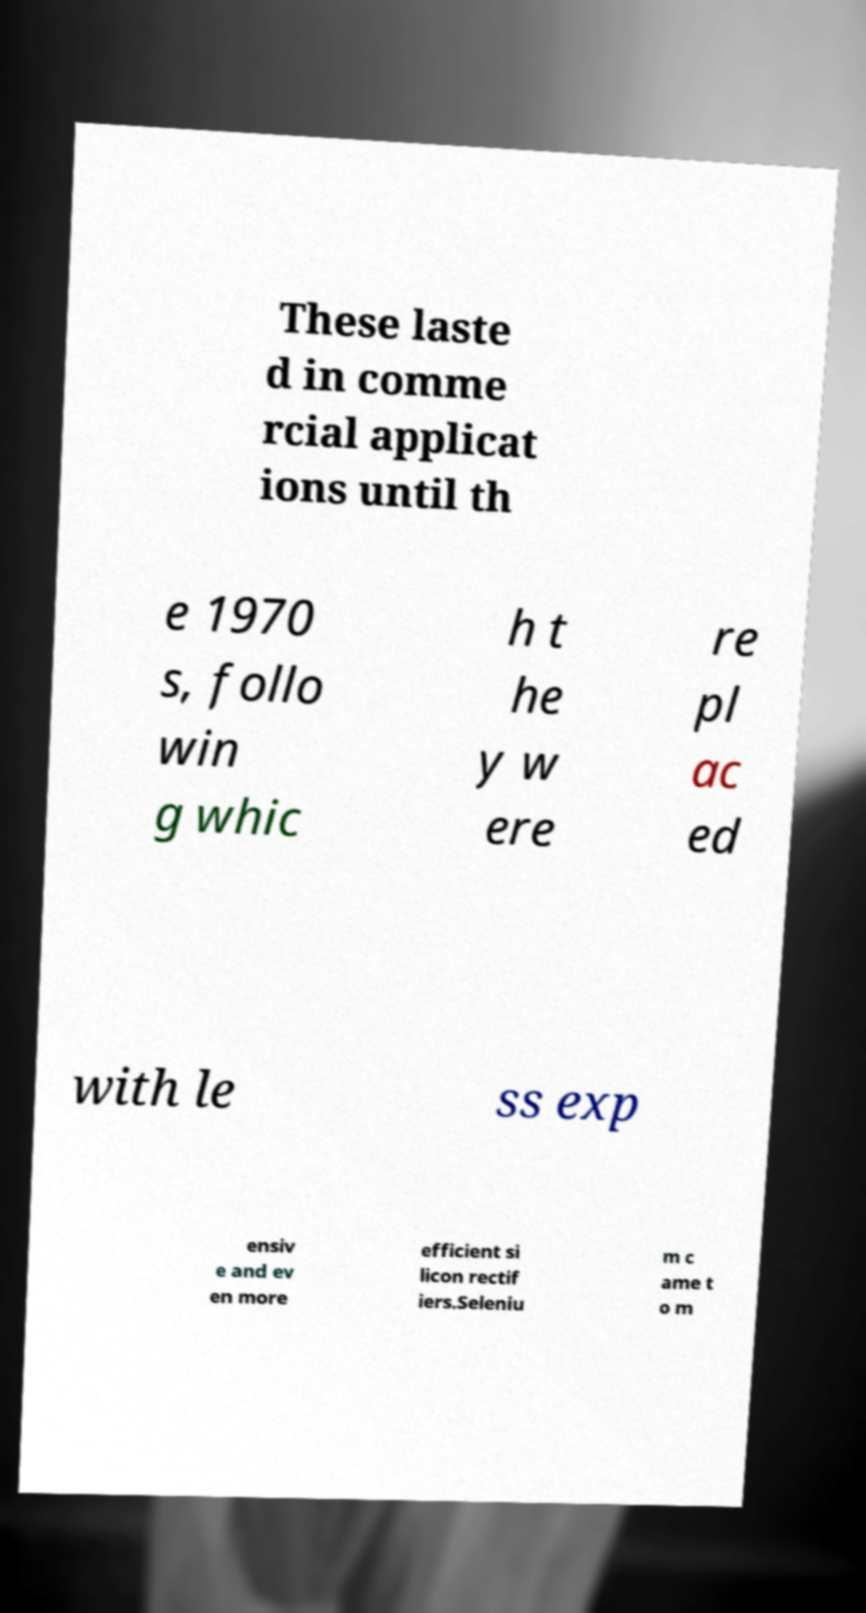Can you read and provide the text displayed in the image?This photo seems to have some interesting text. Can you extract and type it out for me? These laste d in comme rcial applicat ions until th e 1970 s, follo win g whic h t he y w ere re pl ac ed with le ss exp ensiv e and ev en more efficient si licon rectif iers.Seleniu m c ame t o m 